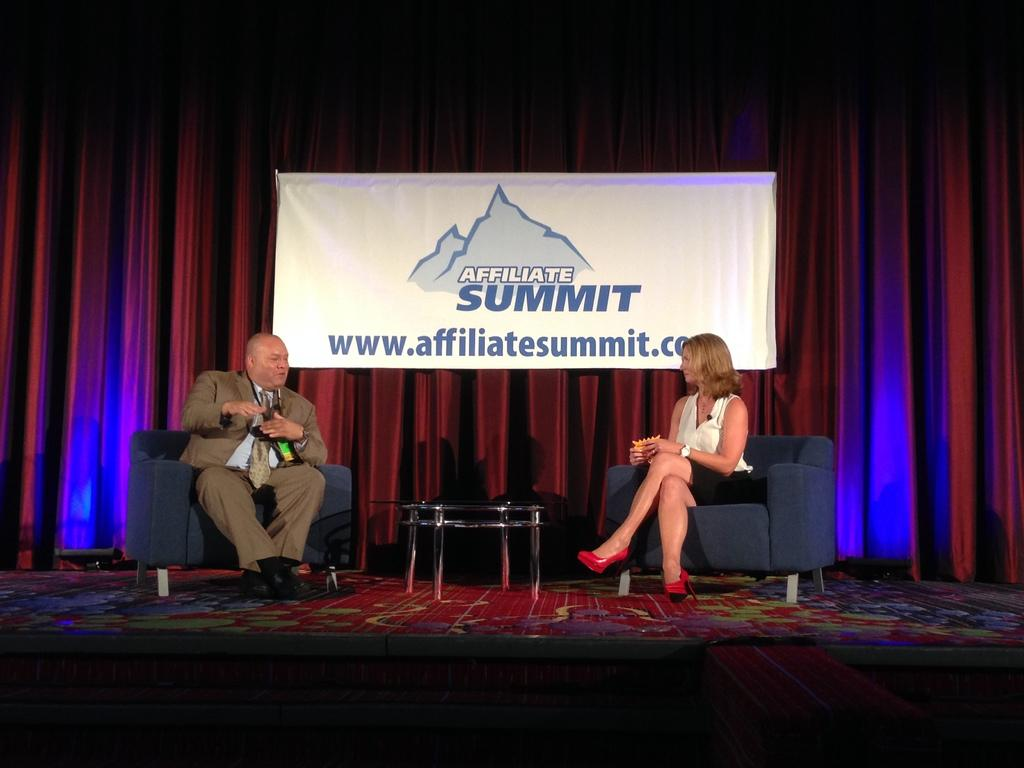How many people are present in the image? There are two people, a man and a woman, present in the image. What are the man and woman doing in the image? Both the man and woman are sitting on chairs. What is in front of the man and woman? There is a table in front of the man and woman. What can be seen in the background of the image? There is a banner and curtains hanging in the background of the image. What type of hair is visible on the brick in the image? There is no brick or hair present in the image. 